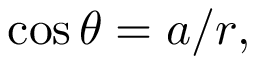Convert formula to latex. <formula><loc_0><loc_0><loc_500><loc_500>\cos \theta = a / r ,</formula> 